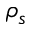Convert formula to latex. <formula><loc_0><loc_0><loc_500><loc_500>\rho _ { s }</formula> 